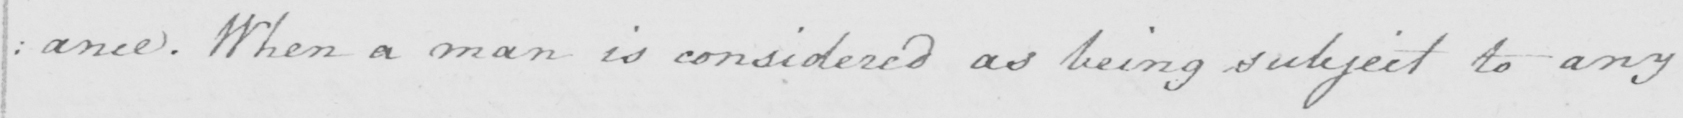Can you tell me what this handwritten text says? : ance . When a man is considered as being subject to any 